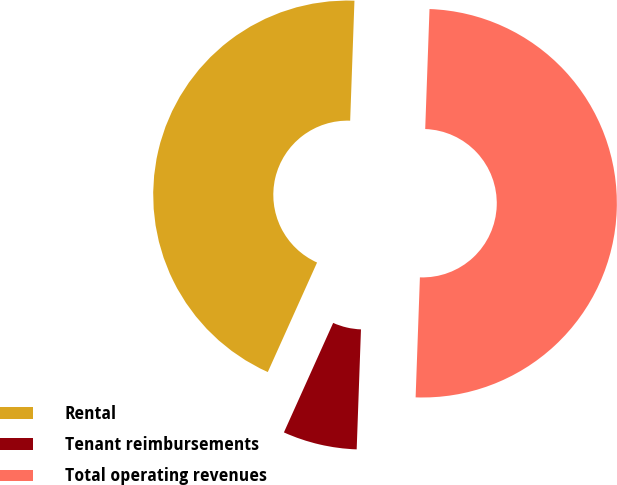<chart> <loc_0><loc_0><loc_500><loc_500><pie_chart><fcel>Rental<fcel>Tenant reimbursements<fcel>Total operating revenues<nl><fcel>43.84%<fcel>6.16%<fcel>50.0%<nl></chart> 